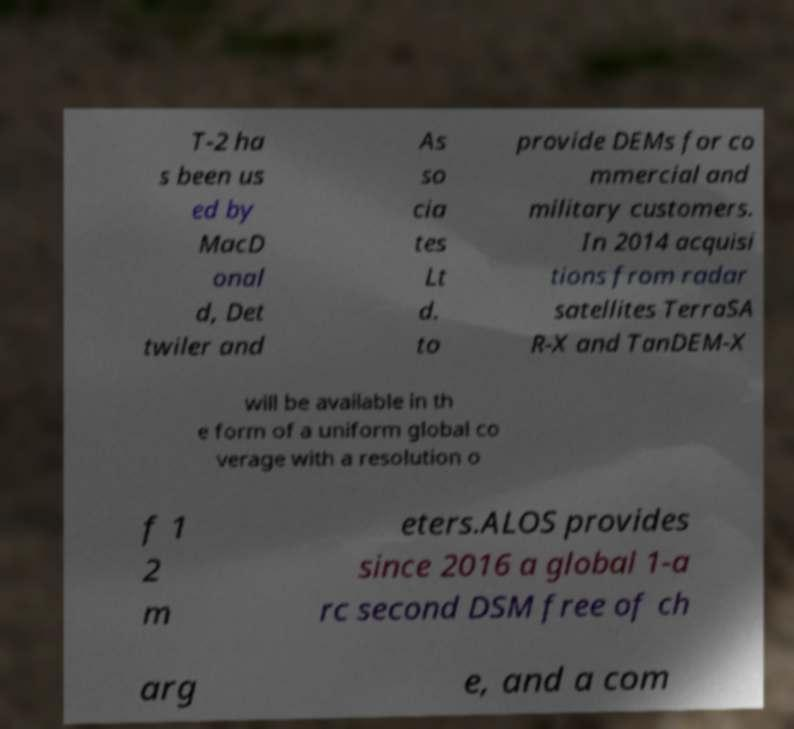Can you accurately transcribe the text from the provided image for me? T-2 ha s been us ed by MacD onal d, Det twiler and As so cia tes Lt d. to provide DEMs for co mmercial and military customers. In 2014 acquisi tions from radar satellites TerraSA R-X and TanDEM-X will be available in th e form of a uniform global co verage with a resolution o f 1 2 m eters.ALOS provides since 2016 a global 1-a rc second DSM free of ch arg e, and a com 